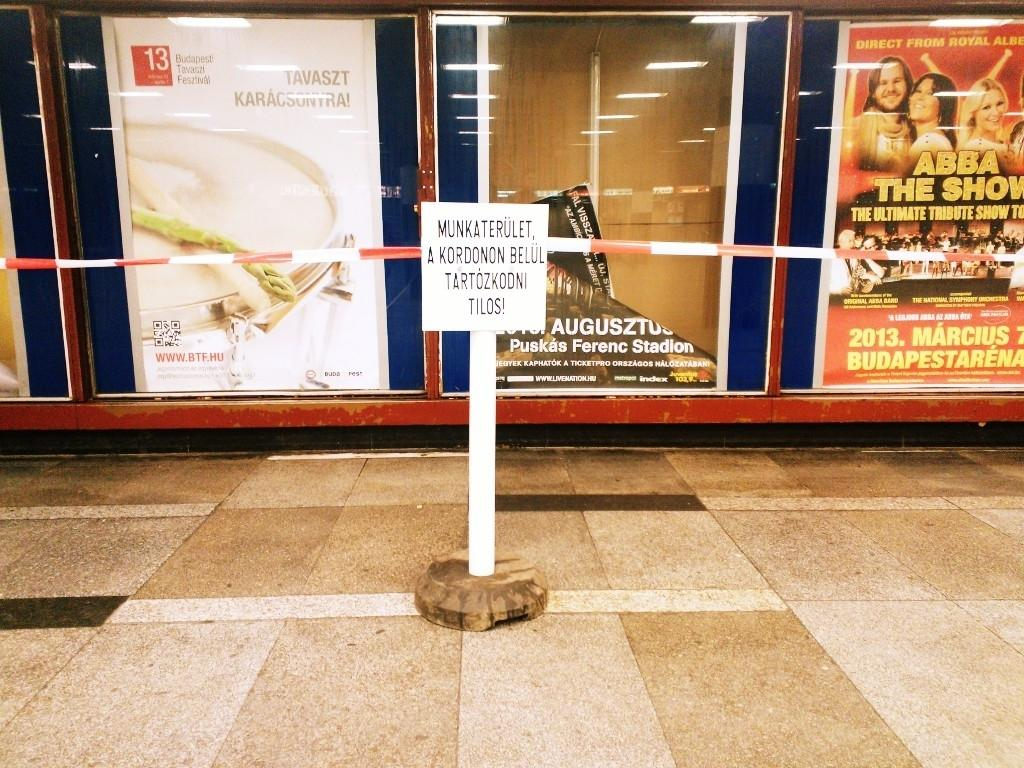<image>
Describe the image concisely. Room with divider and various advertisements on wall including The Abba Show 